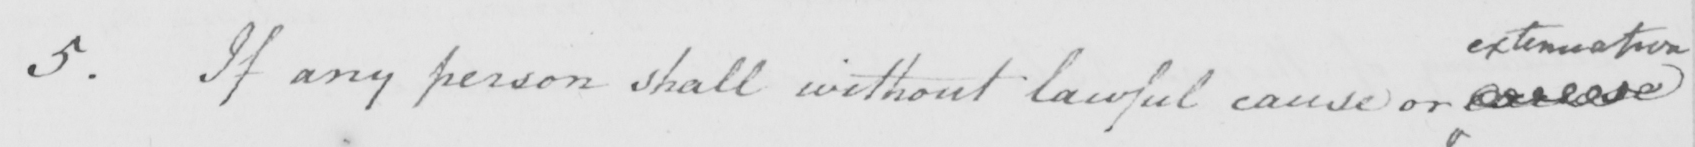Please transcribe the handwritten text in this image. 5 . If any person shall without lawful cause or excuse 